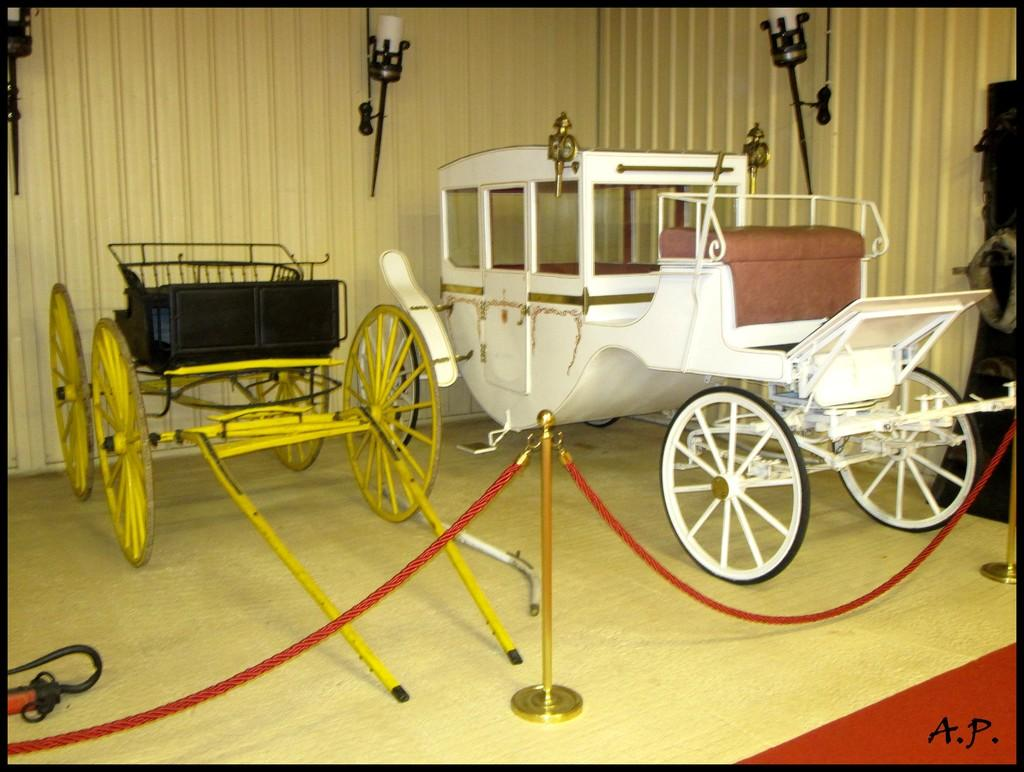What objects are on the floor in the image? There are carts, ropes, and stands on the floor in the image. What can be seen in the bottom right corner of the image? There is text in the bottom right corner of the image. What type of lighting is present in the image? There are lights in the image. What is the background made of in the image? The background is made of wood. How does the elbow contribute to the overall aesthetic of the image? There is no elbow present in the image, so it cannot contribute to the overall aesthetic. 